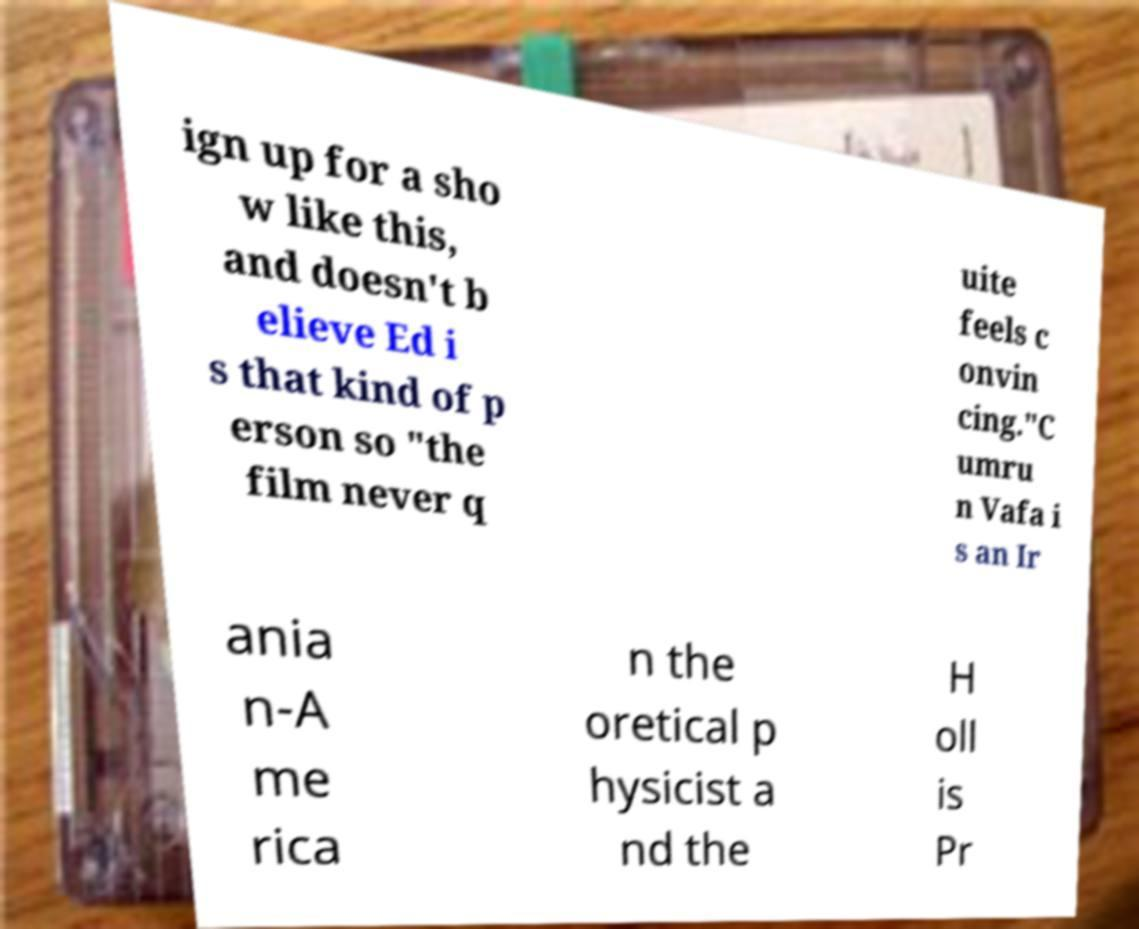Please identify and transcribe the text found in this image. ign up for a sho w like this, and doesn't b elieve Ed i s that kind of p erson so "the film never q uite feels c onvin cing."C umru n Vafa i s an Ir ania n-A me rica n the oretical p hysicist a nd the H oll is Pr 